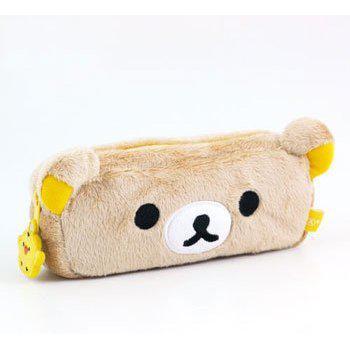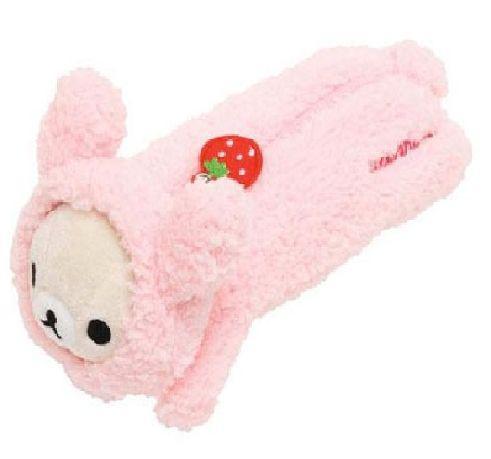The first image is the image on the left, the second image is the image on the right. For the images displayed, is the sentence "There is a plush teddy bear pencil case with a zipper facing to the left in both of the images." factually correct? Answer yes or no. No. The first image is the image on the left, the second image is the image on the right. For the images shown, is this caption "a pencil pouch has a strawberry on the zipper" true? Answer yes or no. Yes. 